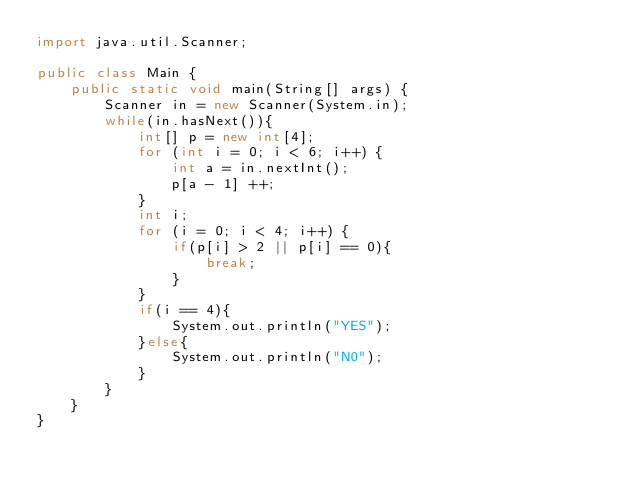Convert code to text. <code><loc_0><loc_0><loc_500><loc_500><_Java_>import java.util.Scanner;

public class Main {
    public static void main(String[] args) {
        Scanner in = new Scanner(System.in);
        while(in.hasNext()){
            int[] p = new int[4];
            for (int i = 0; i < 6; i++) {
                int a = in.nextInt();
                p[a - 1] ++;
            }
            int i;
            for (i = 0; i < 4; i++) {
                if(p[i] > 2 || p[i] == 0){
                    break;
                }
            }
            if(i == 4){
                System.out.println("YES");
            }else{
                System.out.println("N0");
            }
        }
    }
}</code> 